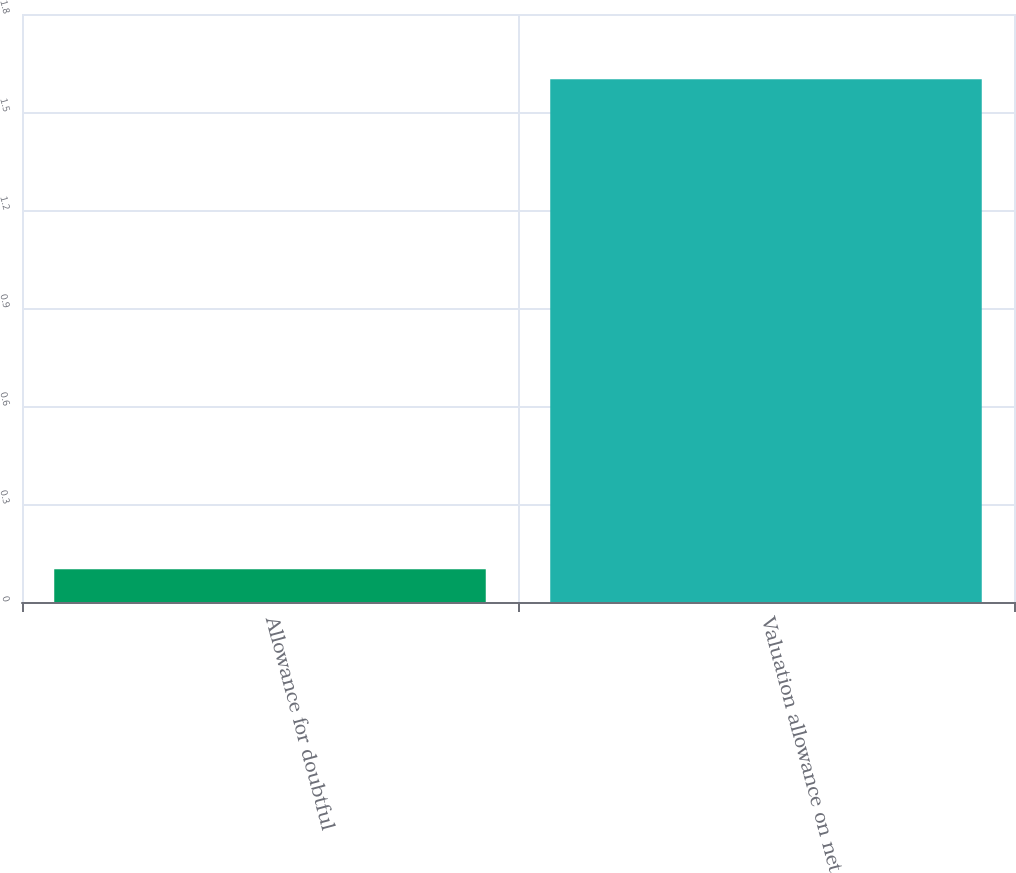<chart> <loc_0><loc_0><loc_500><loc_500><bar_chart><fcel>Allowance for doubtful<fcel>Valuation allowance on net<nl><fcel>0.1<fcel>1.6<nl></chart> 